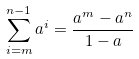Convert formula to latex. <formula><loc_0><loc_0><loc_500><loc_500>\sum _ { i = m } ^ { n - 1 } a ^ { i } = \frac { a ^ { m } - a ^ { n } } { 1 - a }</formula> 